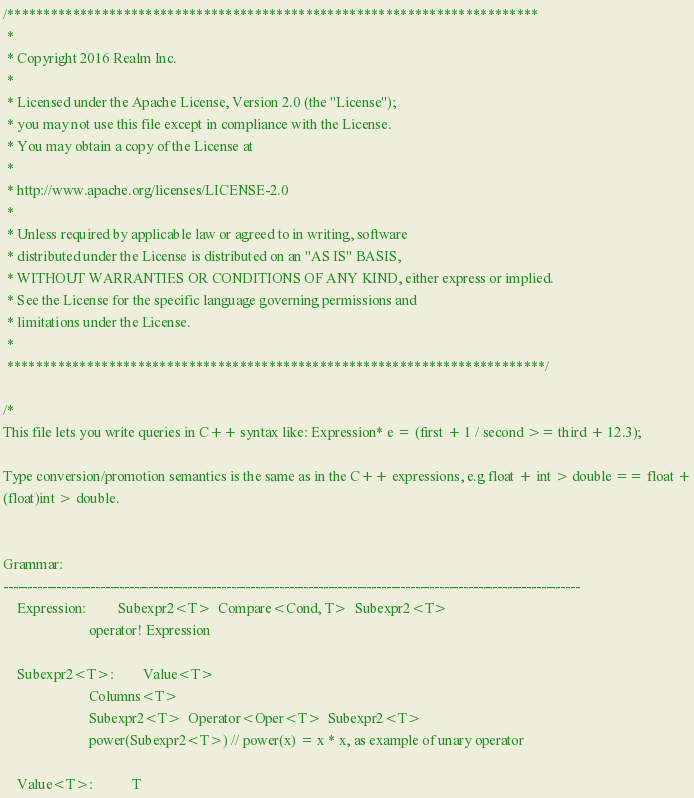Convert code to text. <code><loc_0><loc_0><loc_500><loc_500><_C++_>/*************************************************************************
 *
 * Copyright 2016 Realm Inc.
 *
 * Licensed under the Apache License, Version 2.0 (the "License");
 * you may not use this file except in compliance with the License.
 * You may obtain a copy of the License at
 *
 * http://www.apache.org/licenses/LICENSE-2.0
 *
 * Unless required by applicable law or agreed to in writing, software
 * distributed under the License is distributed on an "AS IS" BASIS,
 * WITHOUT WARRANTIES OR CONDITIONS OF ANY KIND, either express or implied.
 * See the License for the specific language governing permissions and
 * limitations under the License.
 *
 **************************************************************************/

/*
This file lets you write queries in C++ syntax like: Expression* e = (first + 1 / second >= third + 12.3);

Type conversion/promotion semantics is the same as in the C++ expressions, e.g float + int > double == float +
(float)int > double.


Grammar:
-----------------------------------------------------------------------------------------------------------------------
    Expression:         Subexpr2<T>  Compare<Cond, T>  Subexpr2<T>
                        operator! Expression

    Subexpr2<T>:        Value<T>
                        Columns<T>
                        Subexpr2<T>  Operator<Oper<T>  Subexpr2<T>
                        power(Subexpr2<T>) // power(x) = x * x, as example of unary operator

    Value<T>:           T
</code> 